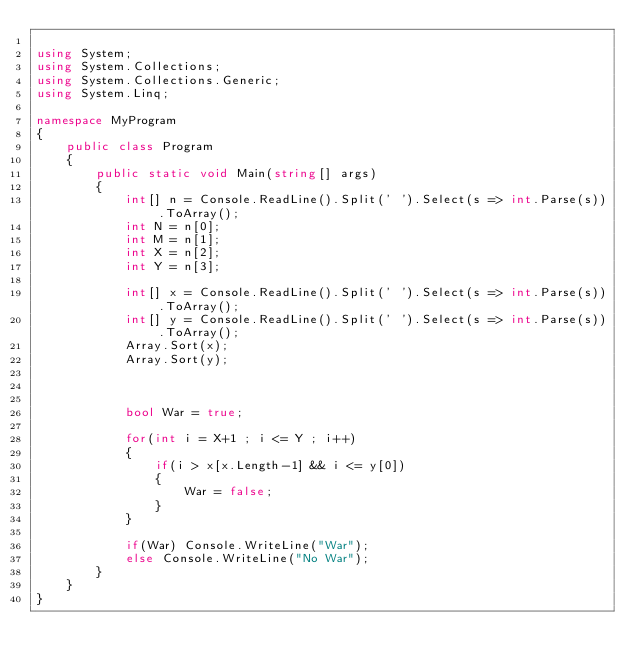Convert code to text. <code><loc_0><loc_0><loc_500><loc_500><_C#_>
using System;
using System.Collections;
using System.Collections.Generic;
using System.Linq;

namespace MyProgram
{
    public class Program
    {	
        public static void Main(string[] args)
        {
            int[] n = Console.ReadLine().Split(' ').Select(s => int.Parse(s)).ToArray();
            int N = n[0];
            int M = n[1];
            int X = n[2];
            int Y = n[3];
            
            int[] x = Console.ReadLine().Split(' ').Select(s => int.Parse(s)).ToArray();
            int[] y = Console.ReadLine().Split(' ').Select(s => int.Parse(s)).ToArray();
            Array.Sort(x);
            Array.Sort(y);
            
         
            
            bool War = true;
            
            for(int i = X+1 ; i <= Y ; i++)
            {
                if(i > x[x.Length-1] && i <= y[0])
                {
                    War = false;
                }
            }
            
            if(War) Console.WriteLine("War");
            else Console.WriteLine("No War");
        }
    }
}</code> 